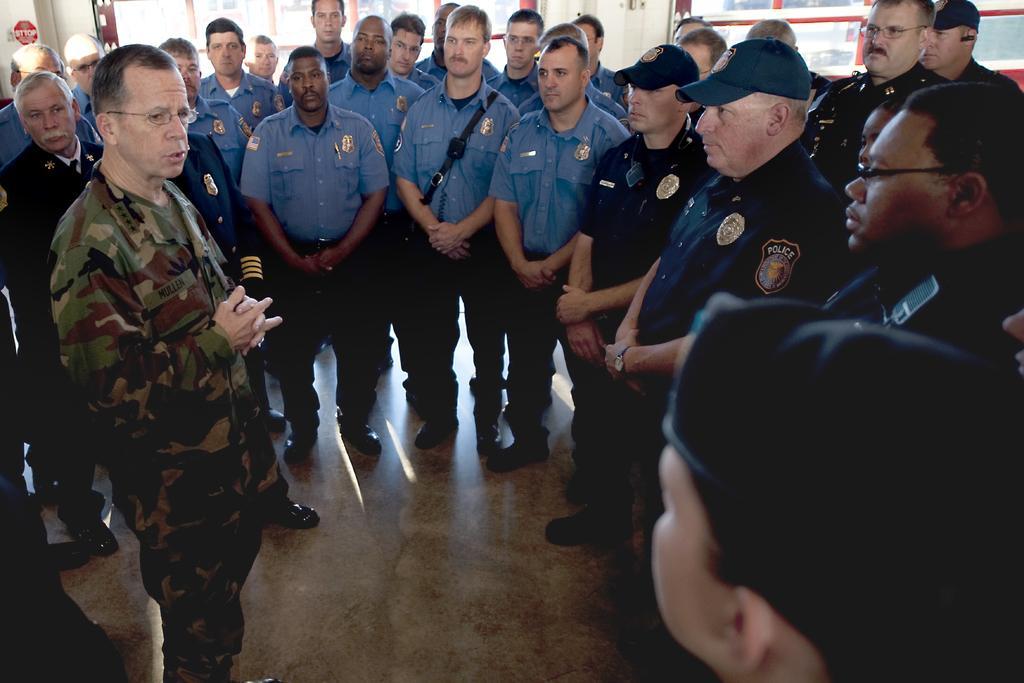Describe this image in one or two sentences. This picture describes about group of people, few people wore spectacles and few people wore caps. 